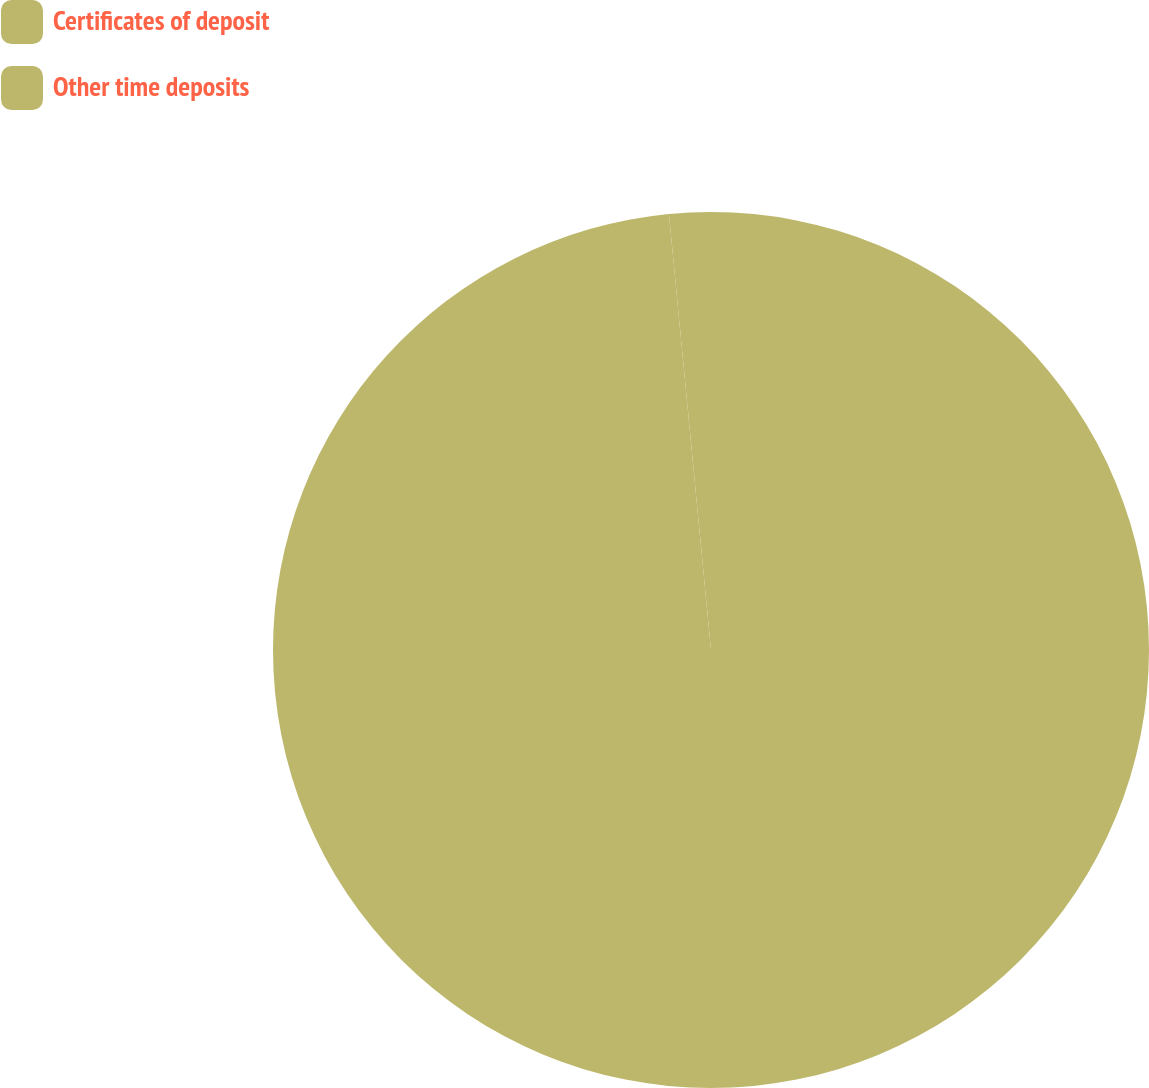Convert chart. <chart><loc_0><loc_0><loc_500><loc_500><pie_chart><fcel>Certificates of deposit<fcel>Other time deposits<nl><fcel>98.47%<fcel>1.53%<nl></chart> 